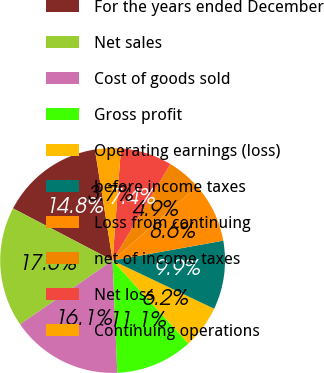Convert chart. <chart><loc_0><loc_0><loc_500><loc_500><pie_chart><fcel>For the years ended December<fcel>Net sales<fcel>Cost of goods sold<fcel>Gross profit<fcel>Operating earnings (loss)<fcel>before income taxes<fcel>Loss from continuing<fcel>net of income taxes<fcel>Net loss<fcel>Continuing operations<nl><fcel>14.81%<fcel>17.28%<fcel>16.05%<fcel>11.11%<fcel>6.17%<fcel>9.88%<fcel>8.64%<fcel>4.94%<fcel>7.41%<fcel>3.7%<nl></chart> 